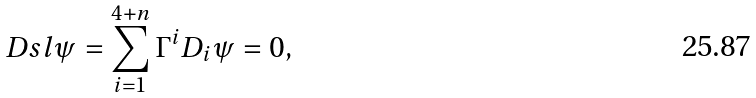Convert formula to latex. <formula><loc_0><loc_0><loc_500><loc_500>\ D s l \psi = \sum _ { i = 1 } ^ { 4 + n } \Gamma ^ { i } D _ { i } \psi = 0 ,</formula> 